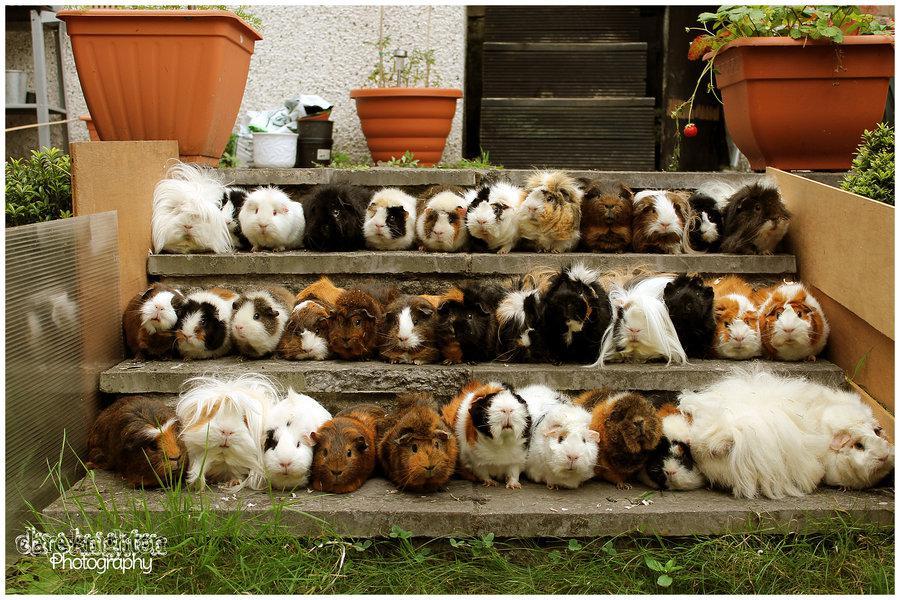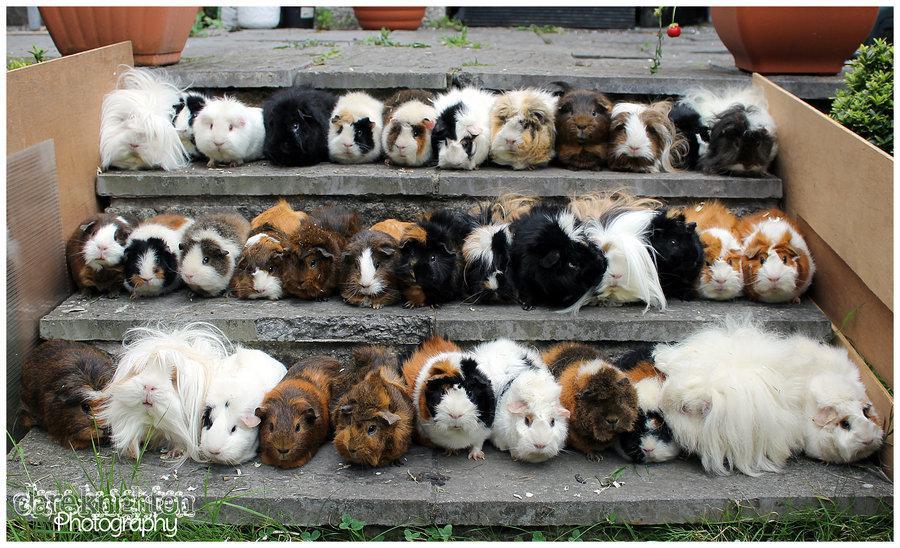The first image is the image on the left, the second image is the image on the right. Assess this claim about the two images: "Both images show a large number of guinea pigs arranged in rows on stair steps.". Correct or not? Answer yes or no. Yes. The first image is the image on the left, the second image is the image on the right. Analyze the images presented: Is the assertion "Both images show variously colored hamsters arranged in stepped rows." valid? Answer yes or no. Yes. 